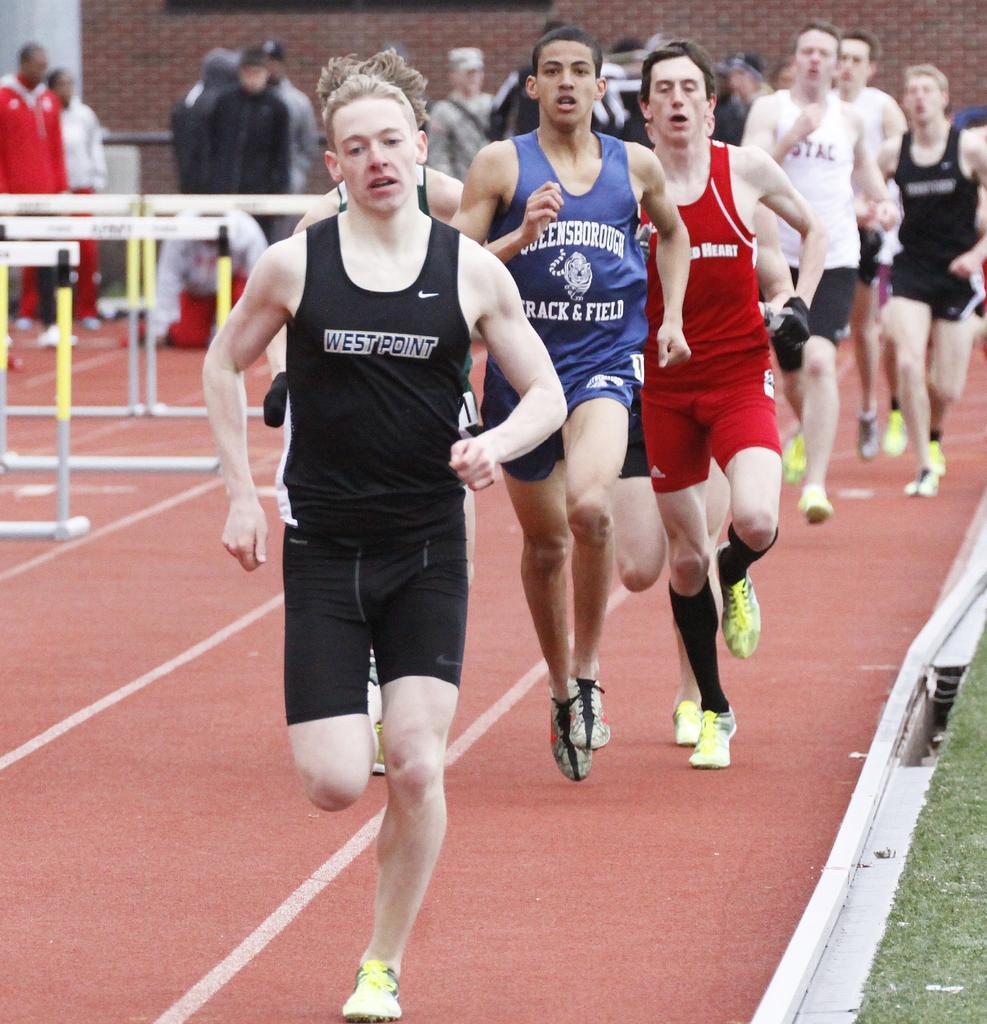In one or two sentences, can you explain what this image depicts? In this image there are many people running on the track. In the background there people , building. Here there are hurdles. 